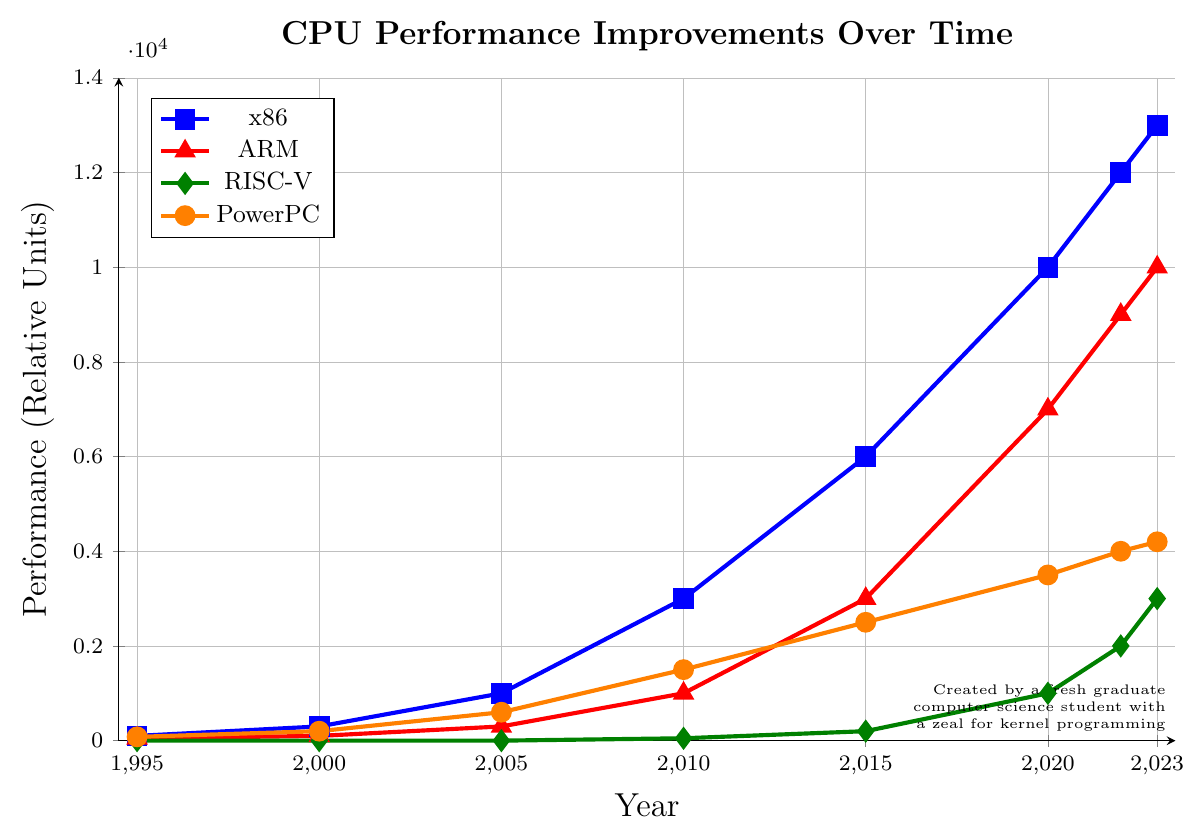How did the performance of x86 architecture change from 1995 to 2023? To determine this, we look at the blue line with square markers representing x86 in the figure. In 1995, the performance was at 100, and in 2023, it increased to 13000. So, x86 performance improved by 12900 units over this period.
Answer: 12900 units Which processor architecture showed no performance in 1995 and began showing performance after 2010? By examining the graph, we see that the green line with diamond markers for RISC-V starts at 0 in 1995 and remains at 0 until 2010 when it begins at 50 units. This indicates that RISC-V had no performance in 1995 and started showing performance after 2010.
Answer: RISC-V Compare the performance of ARM and PowerPC architectures in 2022. Which one is higher and by how much? Looking at the 2022 data points for ARM (red line with triangle markers) and PowerPC (orange line with circle markers), ARM is at 9000 units and PowerPC is at 4000 units. To compare, ARM is higher by 9000 - 4000 = 5000 units.
Answer: ARM by 5000 units What is the trend of ARM performance from 2000 to 2015? To identify the trend, we look at the red line with triangle markers for ARM between these years. In 2000, it was 100 units; in 2005, it increased to 300 units; in 2010, it rose to 1000 units; and by 2015, it reached 3000 units. The trend shows a steady increase.
Answer: Steady increase What unique pattern is observed in RISC-V's performance data compared to other architectures? Noting the green line with diamond markers for RISC-V, we see that it starts at 0 and remains flat until 2010, then begins to rise. In contrast, other architectures show a gradual increase throughout the years. This pattern indicates that RISC-V's performance began significantly later than the others.
Answer: Late start and sharp increase What were the performance levels of all architectures in the year 2020? By examining the data points in the figure for the year 2020: x86 (blue line with squares) shows 10000 units, ARM (red line with triangles) is at 7000 units, RISC-V (green line with diamonds) is at 1000 units, and PowerPC (orange line with circles) is at 3500 units.
Answer: x86: 10000, ARM: 7000, RISC-V: 1000, PowerPC: 3500 Which year did all architectures (excluding RISC-V) show the largest jump in performance collectively? To determine this, we need to compare the annual performance jumps for x86, ARM, and PowerPC between each year pair. The largest jumps for x86, ARM, and PowerPC collectively appear between 2015 and 2020:
- x86: 10000 - 6000 = 4000
- ARM: 7000 - 3000 = 4000
- PowerPC: 3500 - 2500 = 1000
Total jump = 4000 + 4000 + 1000 = 9000 units, the largest compared to other periods.
Answer: 2015-2020 